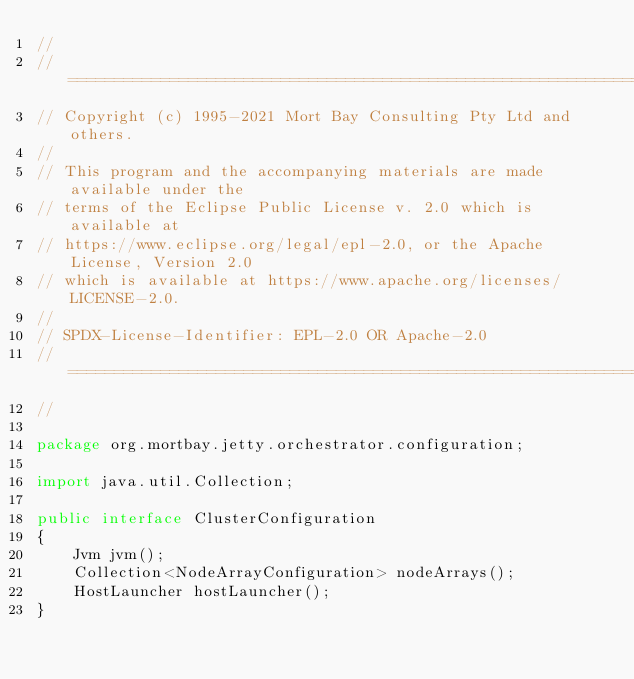<code> <loc_0><loc_0><loc_500><loc_500><_Java_>//
// ========================================================================
// Copyright (c) 1995-2021 Mort Bay Consulting Pty Ltd and others.
//
// This program and the accompanying materials are made available under the
// terms of the Eclipse Public License v. 2.0 which is available at
// https://www.eclipse.org/legal/epl-2.0, or the Apache License, Version 2.0
// which is available at https://www.apache.org/licenses/LICENSE-2.0.
//
// SPDX-License-Identifier: EPL-2.0 OR Apache-2.0
// ========================================================================
//

package org.mortbay.jetty.orchestrator.configuration;

import java.util.Collection;

public interface ClusterConfiguration
{
    Jvm jvm();
    Collection<NodeArrayConfiguration> nodeArrays();
    HostLauncher hostLauncher();
}
</code> 